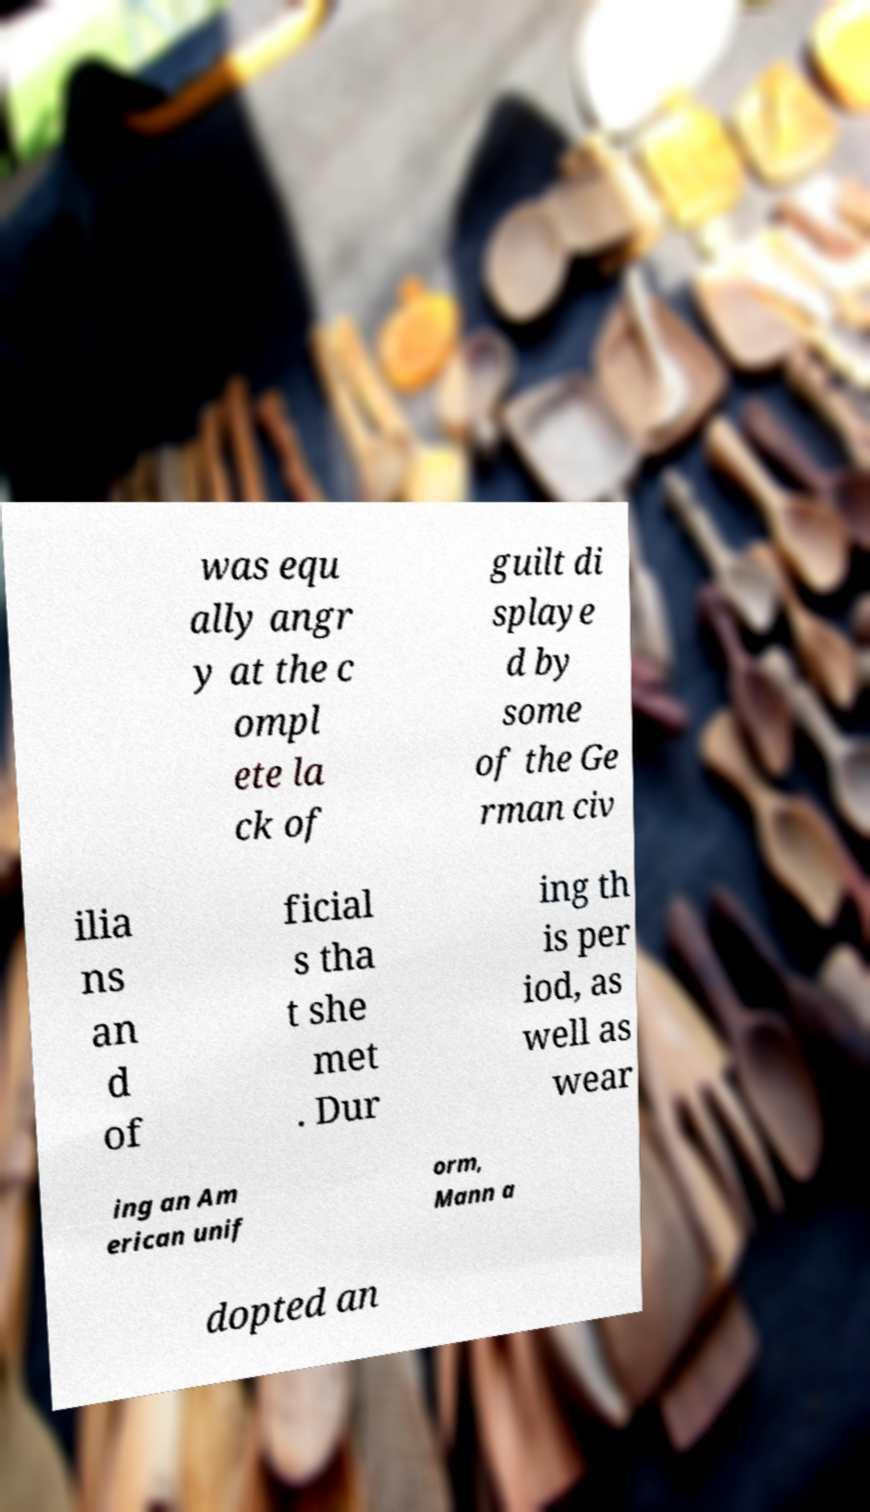I need the written content from this picture converted into text. Can you do that? was equ ally angr y at the c ompl ete la ck of guilt di splaye d by some of the Ge rman civ ilia ns an d of ficial s tha t she met . Dur ing th is per iod, as well as wear ing an Am erican unif orm, Mann a dopted an 